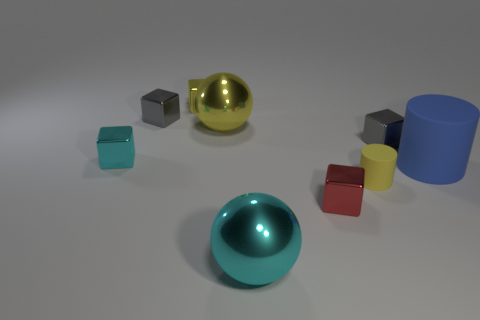Subtract 1 blocks. How many blocks are left? 4 Subtract all yellow blocks. How many blocks are left? 4 Subtract all small cyan blocks. How many blocks are left? 4 Subtract all brown blocks. Subtract all yellow cylinders. How many blocks are left? 5 Add 1 big blue objects. How many objects exist? 10 Subtract all spheres. How many objects are left? 7 Add 9 large cyan metallic things. How many large cyan metallic things exist? 10 Subtract 0 green cylinders. How many objects are left? 9 Subtract all yellow metallic spheres. Subtract all spheres. How many objects are left? 6 Add 4 blue things. How many blue things are left? 5 